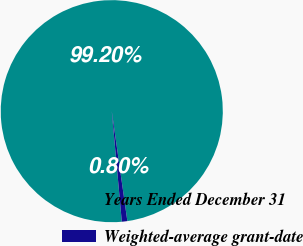Convert chart to OTSL. <chart><loc_0><loc_0><loc_500><loc_500><pie_chart><fcel>Years Ended December 31<fcel>Weighted-average grant-date<nl><fcel>99.2%<fcel>0.8%<nl></chart> 